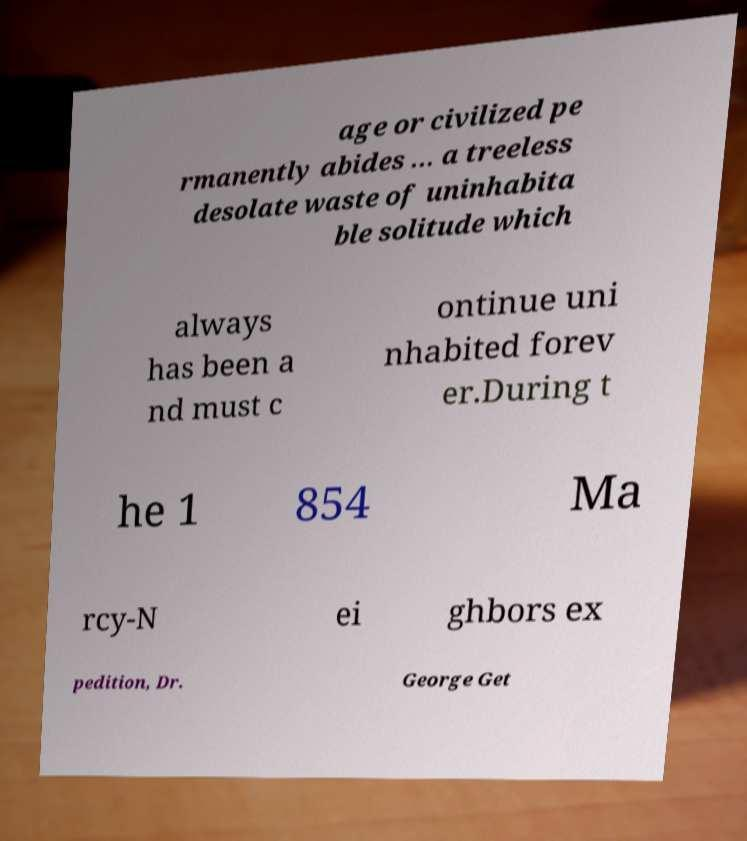There's text embedded in this image that I need extracted. Can you transcribe it verbatim? age or civilized pe rmanently abides ... a treeless desolate waste of uninhabita ble solitude which always has been a nd must c ontinue uni nhabited forev er.During t he 1 854 Ma rcy-N ei ghbors ex pedition, Dr. George Get 